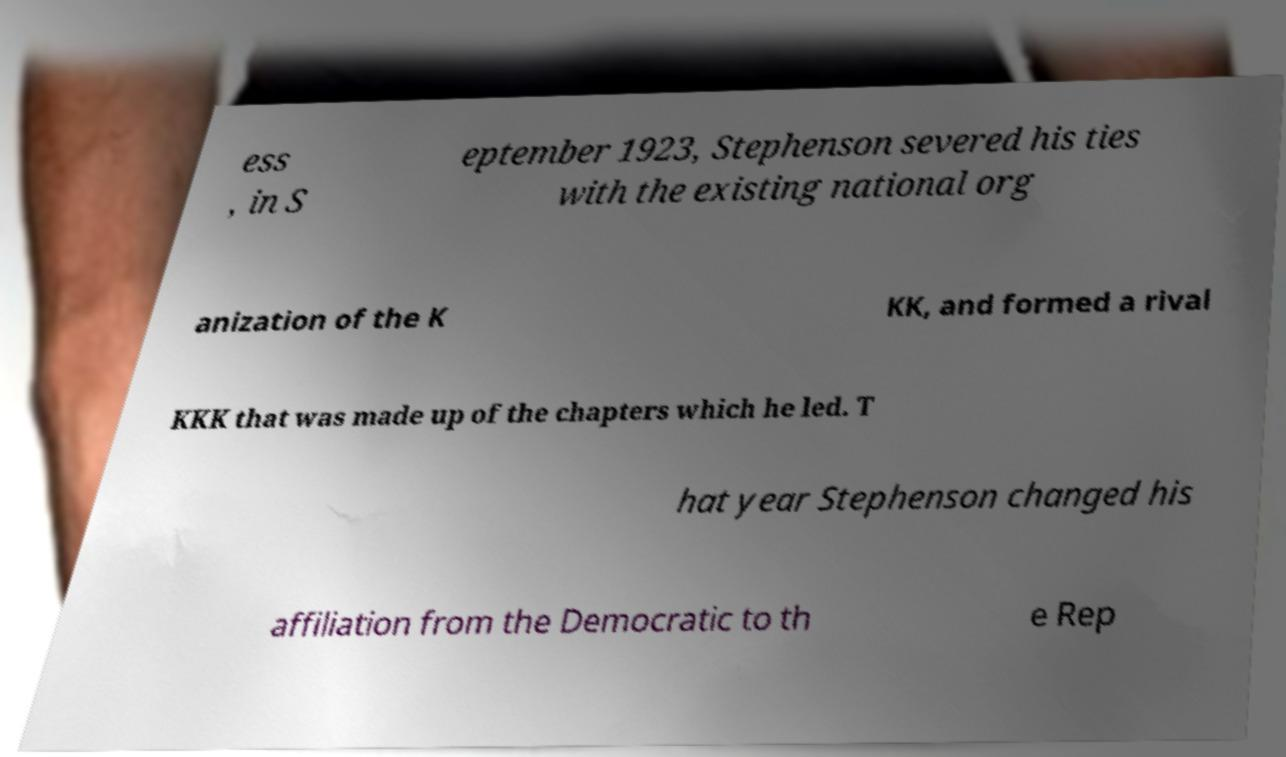Please read and relay the text visible in this image. What does it say? ess , in S eptember 1923, Stephenson severed his ties with the existing national org anization of the K KK, and formed a rival KKK that was made up of the chapters which he led. T hat year Stephenson changed his affiliation from the Democratic to th e Rep 